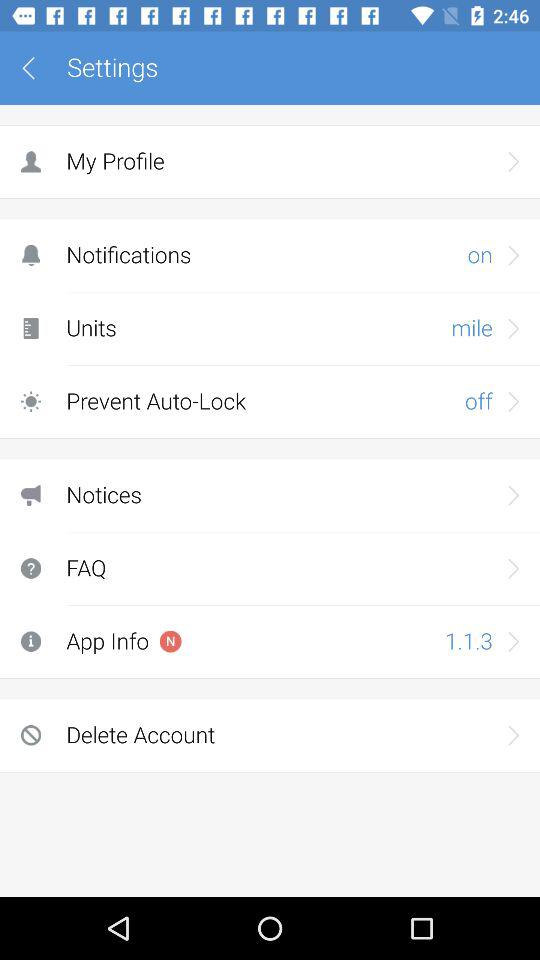Which unit was selected? The selected unit was miles. 